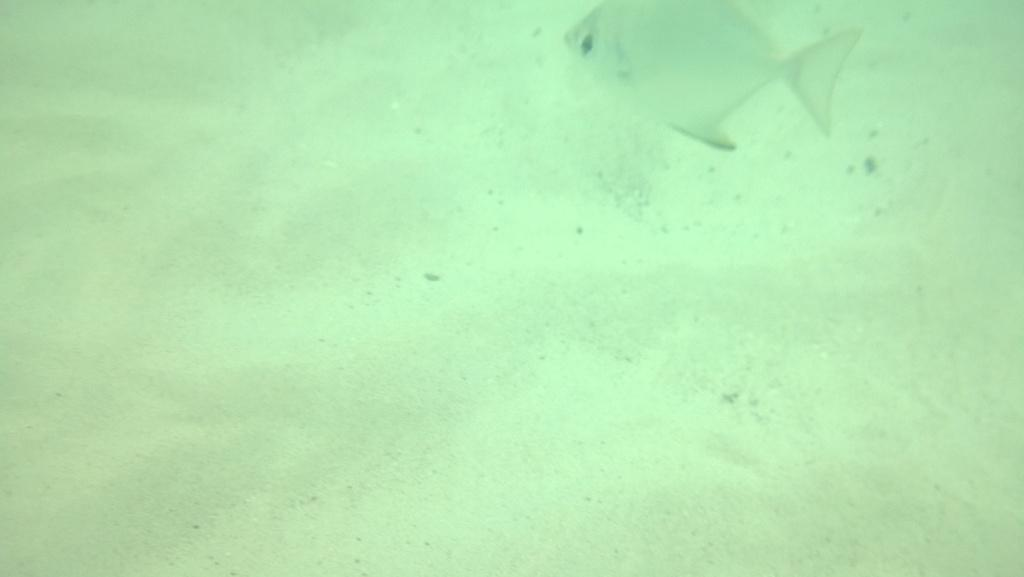Where is the location of the image? The image is underground. What can be seen in the image besides the underground setting? There is water and white sand in the image. What type of creature is present in the water? A fish is swimming in the water. What type of pies can be seen in the image? There are no pies present in the image; it features an underground setting with water and a fish swimming in it. 